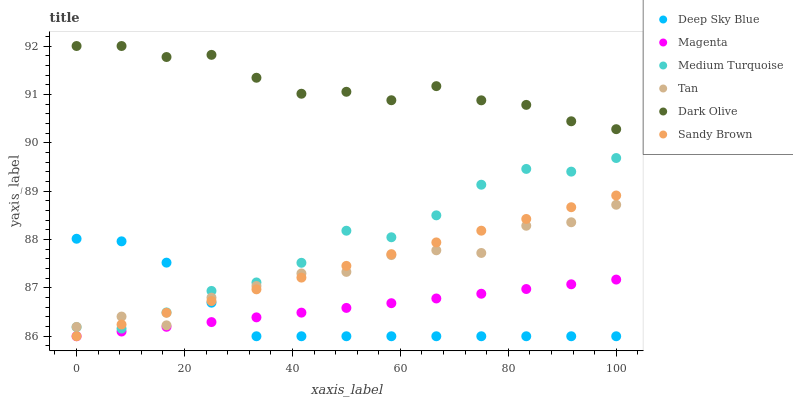Does Deep Sky Blue have the minimum area under the curve?
Answer yes or no. Yes. Does Dark Olive have the maximum area under the curve?
Answer yes or no. Yes. Does Medium Turquoise have the minimum area under the curve?
Answer yes or no. No. Does Medium Turquoise have the maximum area under the curve?
Answer yes or no. No. Is Magenta the smoothest?
Answer yes or no. Yes. Is Tan the roughest?
Answer yes or no. Yes. Is Dark Olive the smoothest?
Answer yes or no. No. Is Dark Olive the roughest?
Answer yes or no. No. Does Deep Sky Blue have the lowest value?
Answer yes or no. Yes. Does Medium Turquoise have the lowest value?
Answer yes or no. No. Does Dark Olive have the highest value?
Answer yes or no. Yes. Does Medium Turquoise have the highest value?
Answer yes or no. No. Is Sandy Brown less than Dark Olive?
Answer yes or no. Yes. Is Medium Turquoise greater than Magenta?
Answer yes or no. Yes. Does Medium Turquoise intersect Sandy Brown?
Answer yes or no. Yes. Is Medium Turquoise less than Sandy Brown?
Answer yes or no. No. Is Medium Turquoise greater than Sandy Brown?
Answer yes or no. No. Does Sandy Brown intersect Dark Olive?
Answer yes or no. No. 